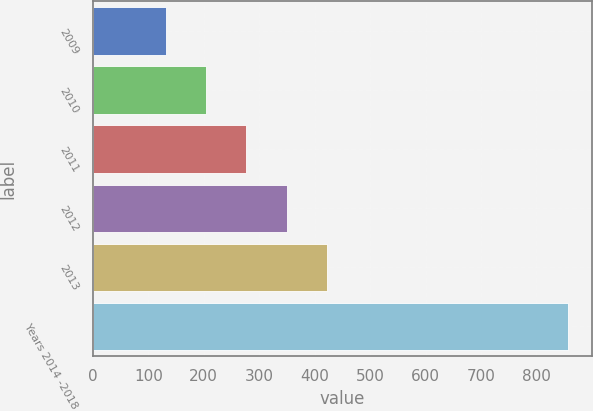<chart> <loc_0><loc_0><loc_500><loc_500><bar_chart><fcel>2009<fcel>2010<fcel>2011<fcel>2012<fcel>2013<fcel>Years 2014 -2018<nl><fcel>132<fcel>204.5<fcel>277<fcel>349.5<fcel>422<fcel>857<nl></chart> 